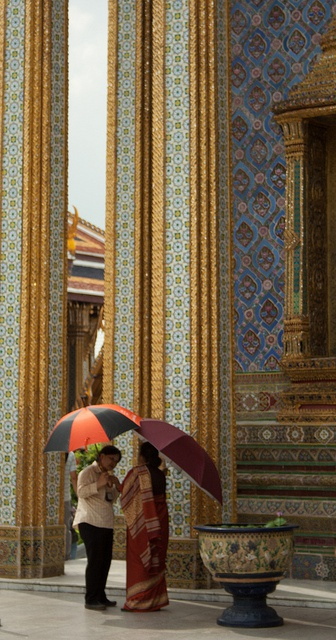Describe the objects in this image and their specific colors. I can see potted plant in tan, black, and gray tones, people in tan, maroon, black, and gray tones, people in tan, black, maroon, and gray tones, umbrella in tan, black, red, gray, and salmon tones, and umbrella in tan, black, maroon, and gray tones in this image. 